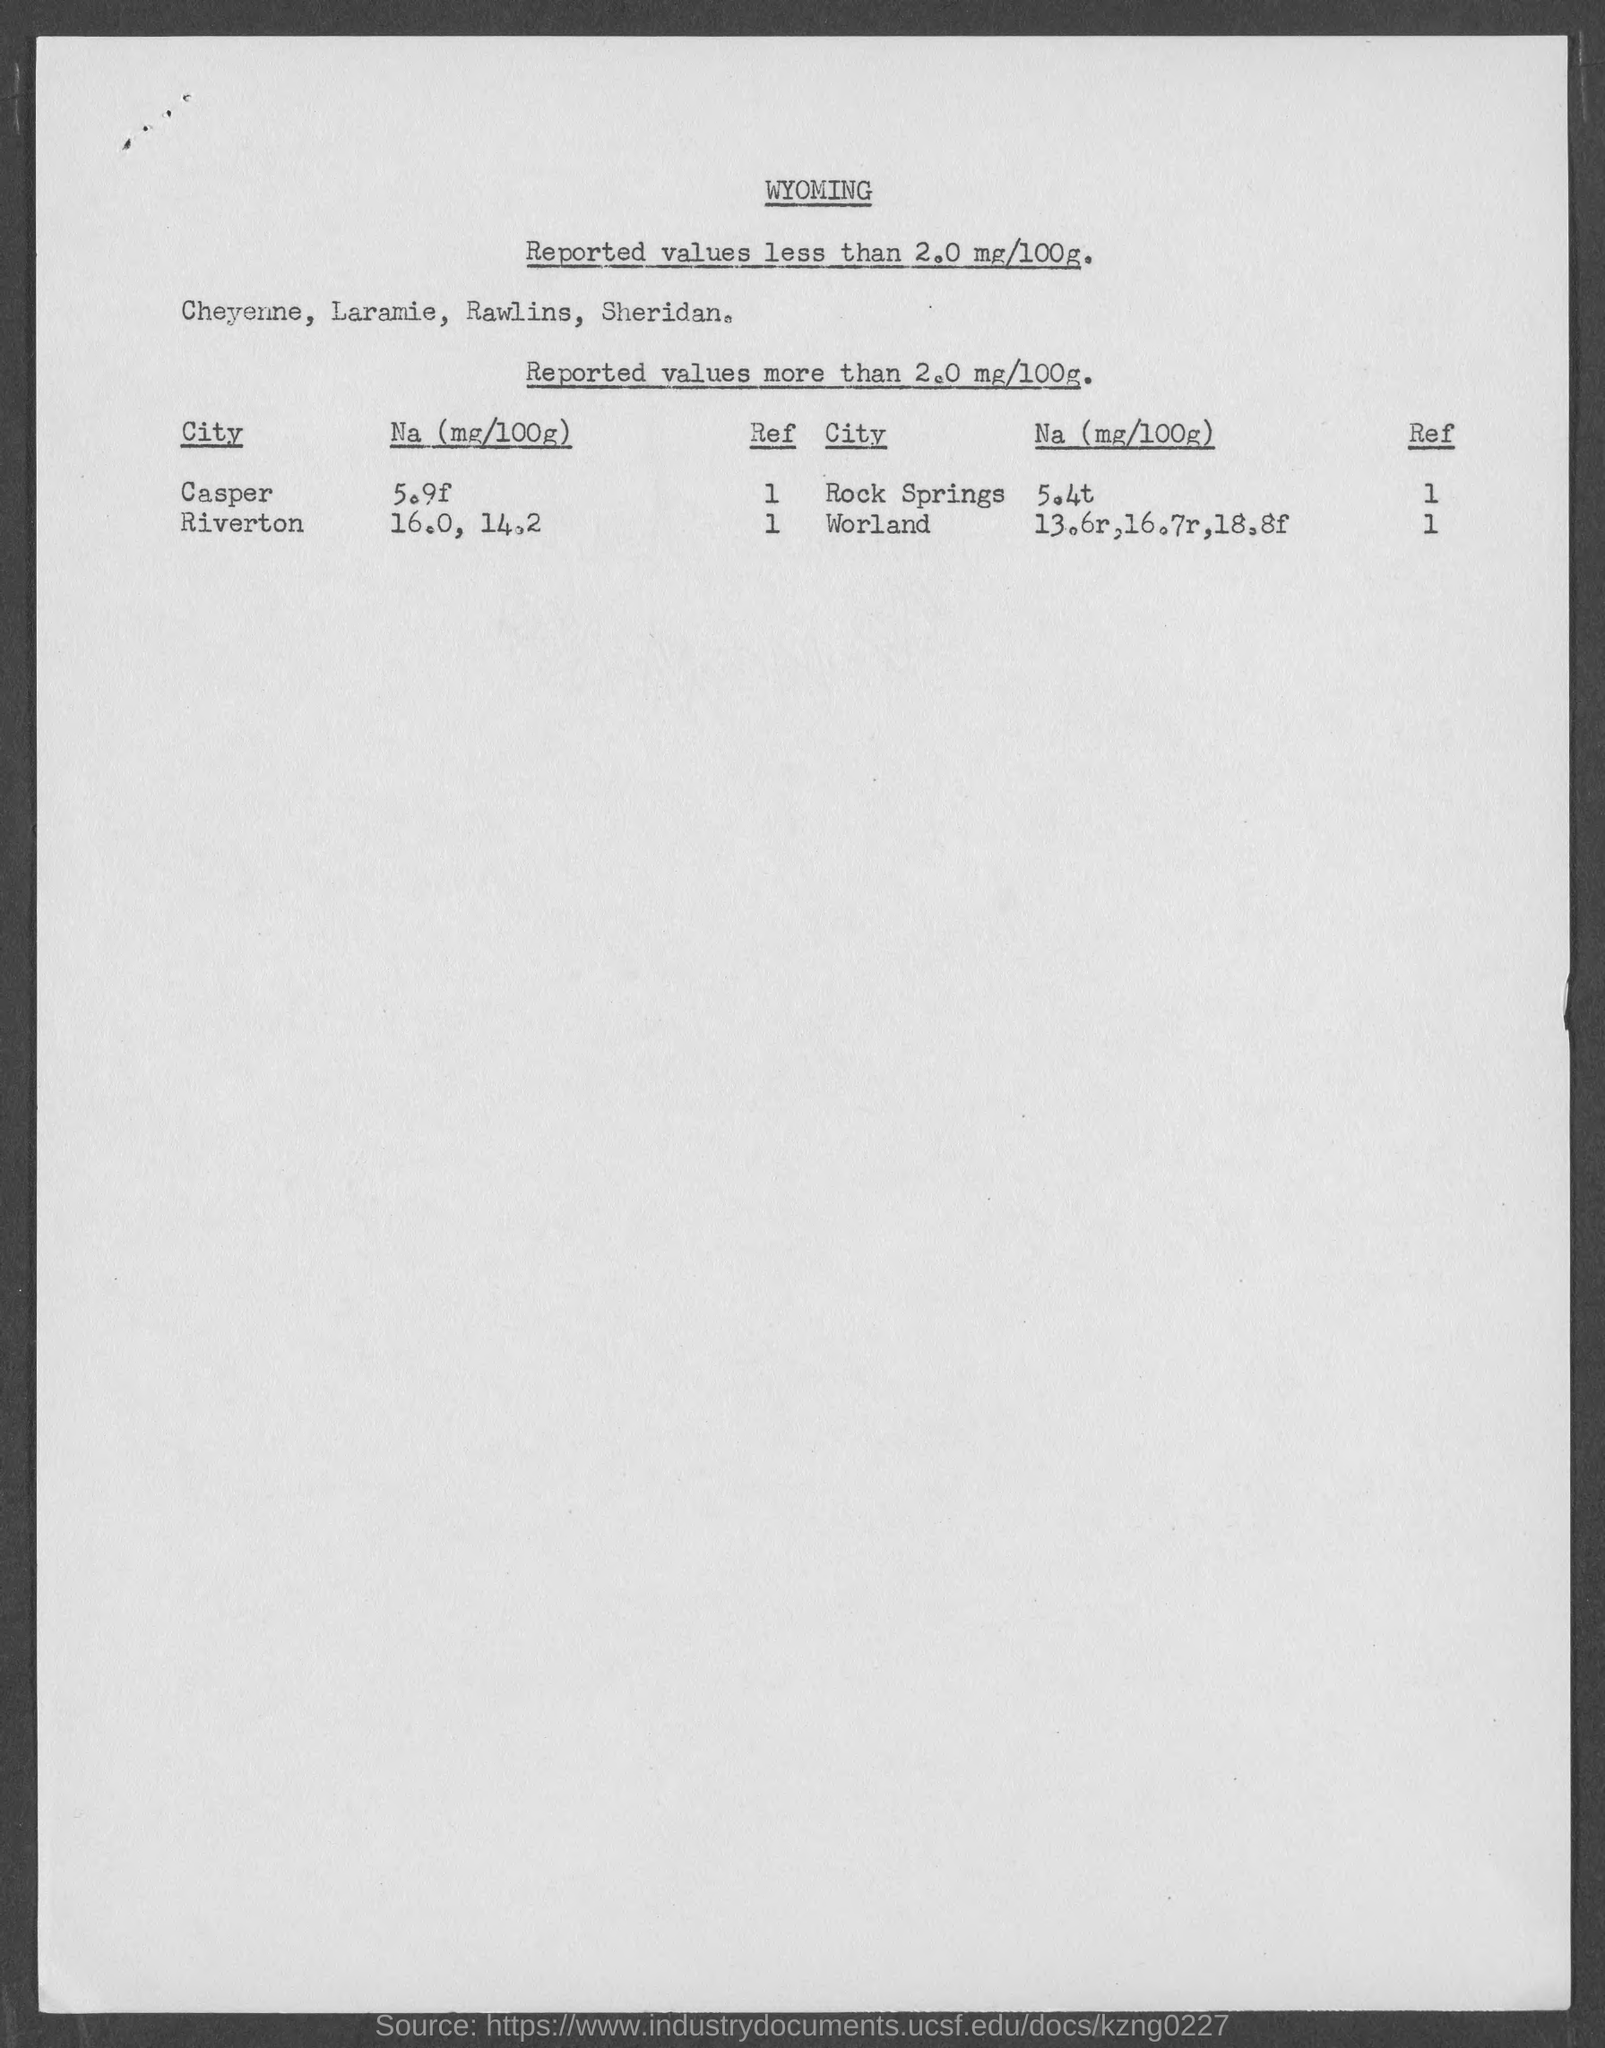What is the first title in the document?
Keep it short and to the point. WYOMING. What is the ref value of the city Casper?
Your response must be concise. 1. What is the ref value of the city Worland?
Your response must be concise. 1. What is the Na value for the city Casper?
Make the answer very short. 5.9f. What is the Na value for the city Rock Springs?
Offer a very short reply. 5.4t. 